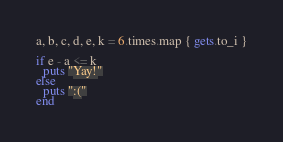<code> <loc_0><loc_0><loc_500><loc_500><_Ruby_>a, b, c, d, e, k = 6.times.map { gets.to_i }
 
if e - a <= k
  puts "Yay!"
else
  puts ":("
end</code> 